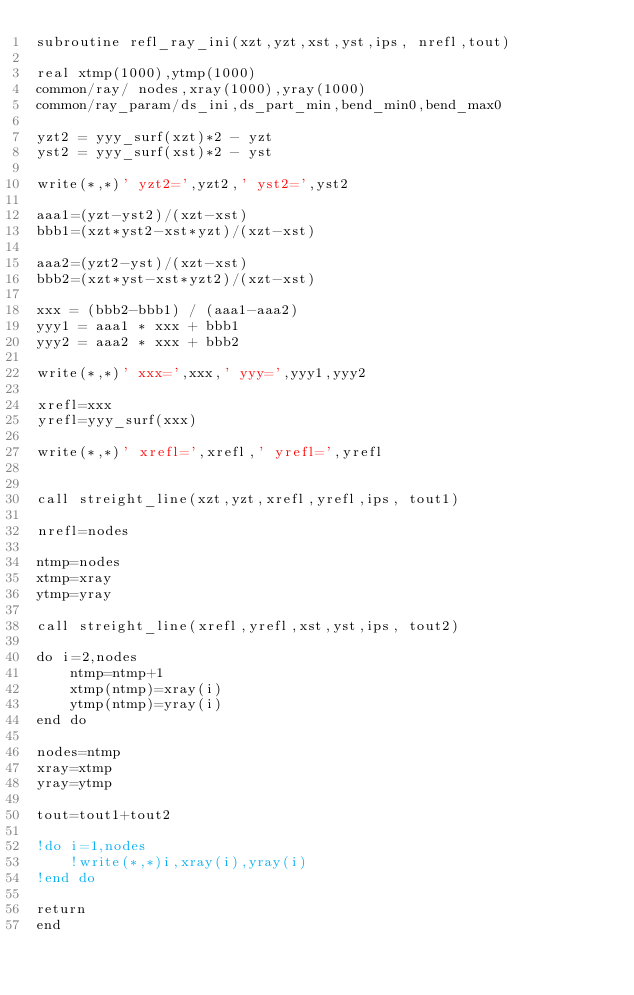Convert code to text. <code><loc_0><loc_0><loc_500><loc_500><_FORTRAN_>subroutine refl_ray_ini(xzt,yzt,xst,yst,ips, nrefl,tout)

real xtmp(1000),ytmp(1000)
common/ray/ nodes,xray(1000),yray(1000)
common/ray_param/ds_ini,ds_part_min,bend_min0,bend_max0

yzt2 = yyy_surf(xzt)*2 - yzt
yst2 = yyy_surf(xst)*2 - yst

write(*,*)' yzt2=',yzt2,' yst2=',yst2

aaa1=(yzt-yst2)/(xzt-xst)
bbb1=(xzt*yst2-xst*yzt)/(xzt-xst)

aaa2=(yzt2-yst)/(xzt-xst)
bbb2=(xzt*yst-xst*yzt2)/(xzt-xst)

xxx = (bbb2-bbb1) / (aaa1-aaa2)
yyy1 = aaa1 * xxx + bbb1
yyy2 = aaa2 * xxx + bbb2

write(*,*)' xxx=',xxx,' yyy=',yyy1,yyy2

xrefl=xxx
yrefl=yyy_surf(xxx)

write(*,*)' xrefl=',xrefl,' yrefl=',yrefl


call streight_line(xzt,yzt,xrefl,yrefl,ips, tout1)

nrefl=nodes

ntmp=nodes
xtmp=xray
ytmp=yray

call streight_line(xrefl,yrefl,xst,yst,ips, tout2)

do i=2,nodes
	ntmp=ntmp+1
	xtmp(ntmp)=xray(i)
	ytmp(ntmp)=yray(i)
end do

nodes=ntmp
xray=xtmp
yray=ytmp

tout=tout1+tout2

!do i=1,nodes
	!write(*,*)i,xray(i),yray(i)
!end do

return
end</code> 